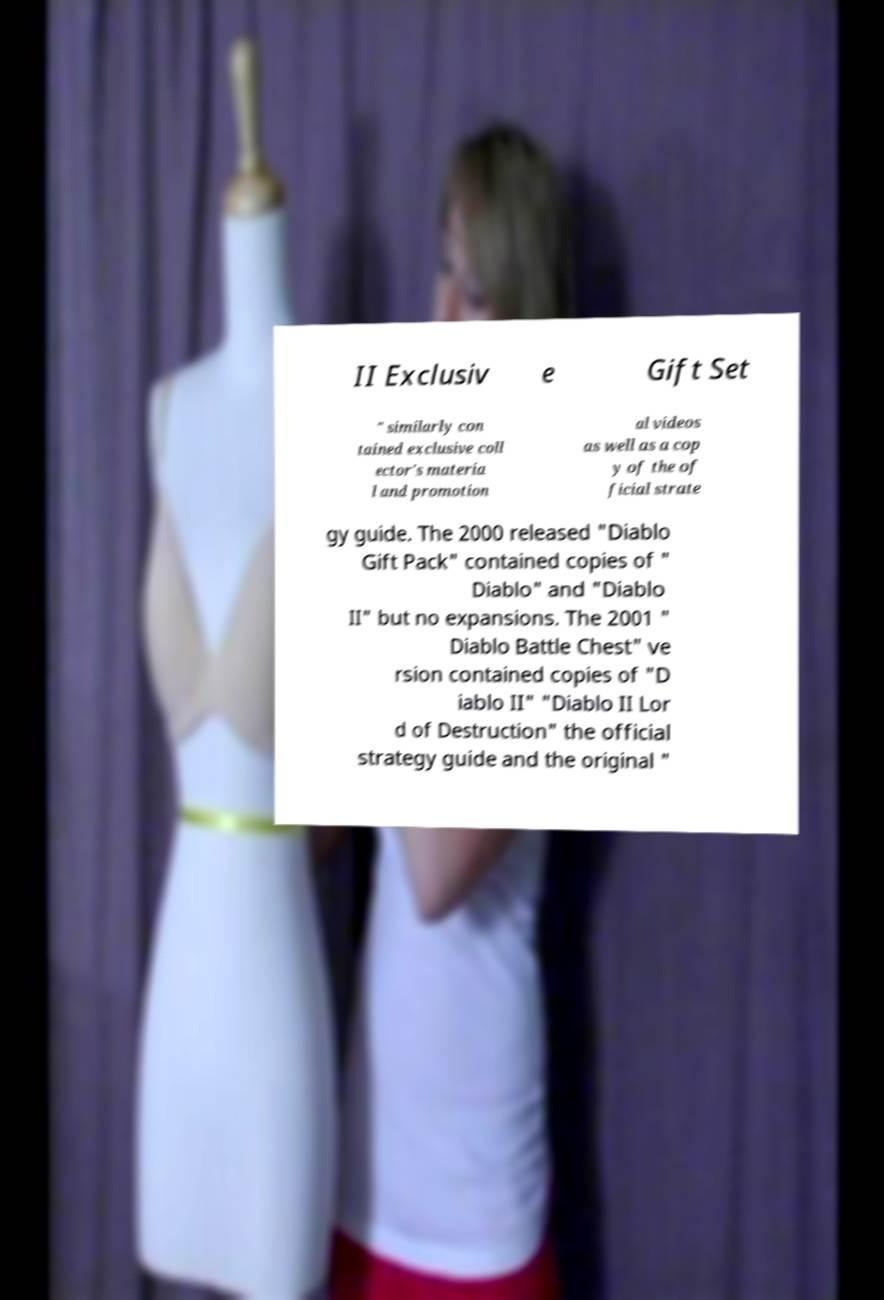Please read and relay the text visible in this image. What does it say? II Exclusiv e Gift Set " similarly con tained exclusive coll ector's materia l and promotion al videos as well as a cop y of the of ficial strate gy guide. The 2000 released "Diablo Gift Pack" contained copies of " Diablo" and "Diablo II" but no expansions. The 2001 " Diablo Battle Chest" ve rsion contained copies of "D iablo II" "Diablo II Lor d of Destruction" the official strategy guide and the original " 